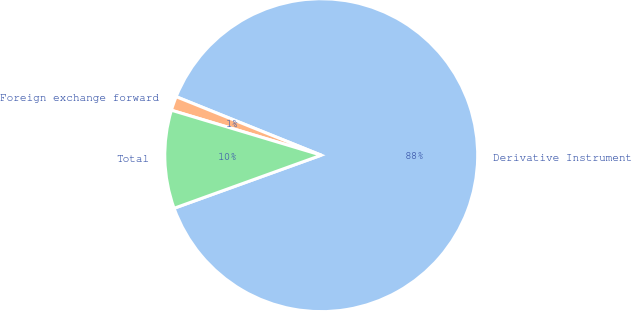<chart> <loc_0><loc_0><loc_500><loc_500><pie_chart><fcel>Derivative Instrument<fcel>Foreign exchange forward<fcel>Total<nl><fcel>88.39%<fcel>1.46%<fcel>10.15%<nl></chart> 